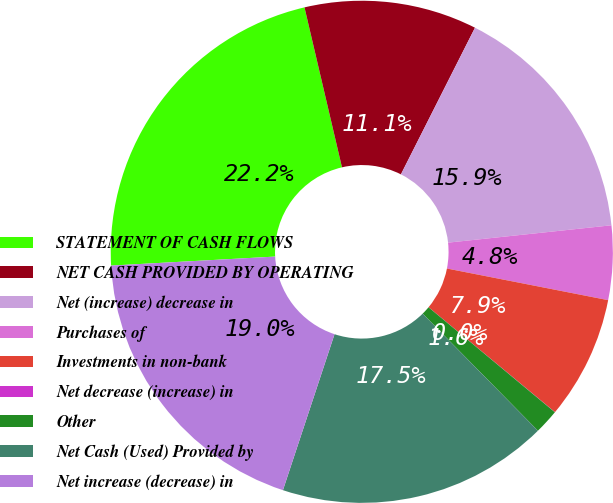<chart> <loc_0><loc_0><loc_500><loc_500><pie_chart><fcel>STATEMENT OF CASH FLOWS<fcel>NET CASH PROVIDED BY OPERATING<fcel>Net (increase) decrease in<fcel>Purchases of<fcel>Investments in non-bank<fcel>Net decrease (increase) in<fcel>Other<fcel>Net Cash (Used) Provided by<fcel>Net increase (decrease) in<nl><fcel>22.21%<fcel>11.11%<fcel>15.87%<fcel>4.77%<fcel>7.94%<fcel>0.01%<fcel>1.59%<fcel>17.46%<fcel>19.04%<nl></chart> 